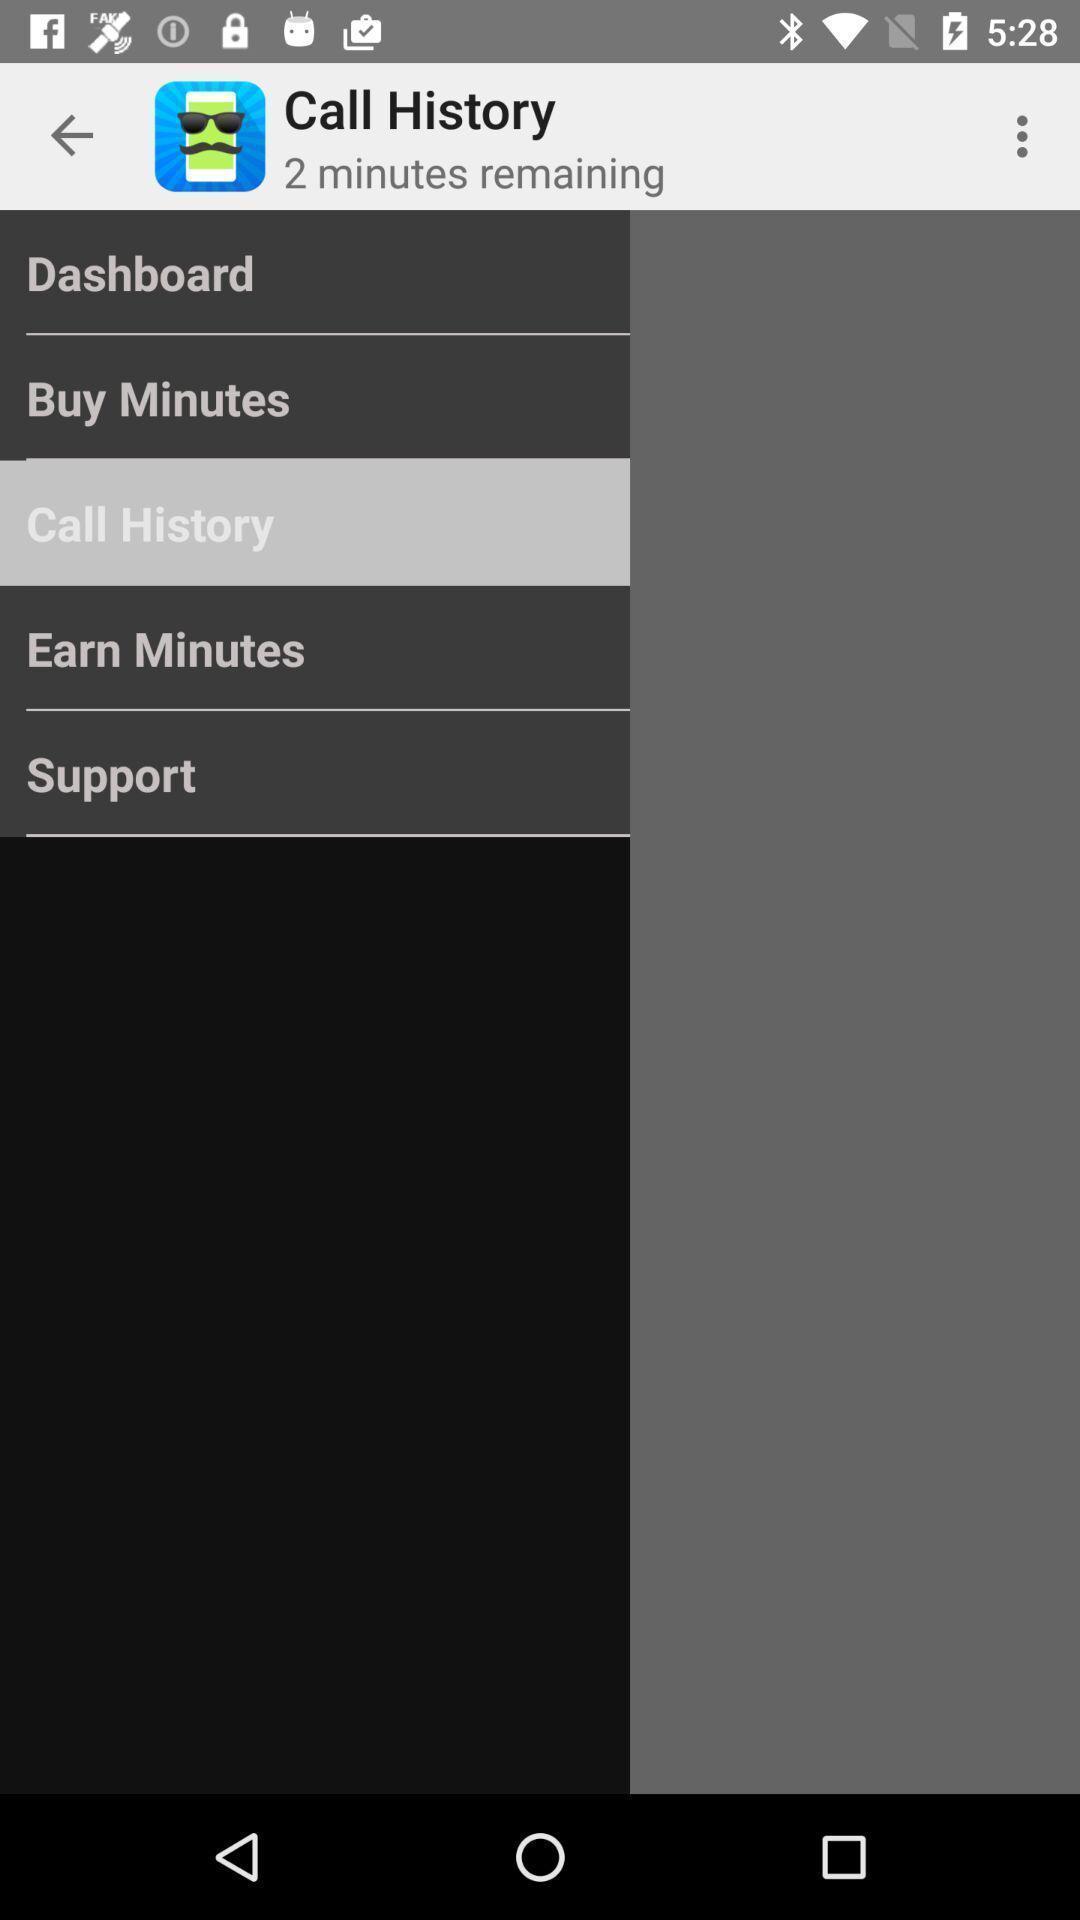Please provide a description for this image. Screen showing call history. 